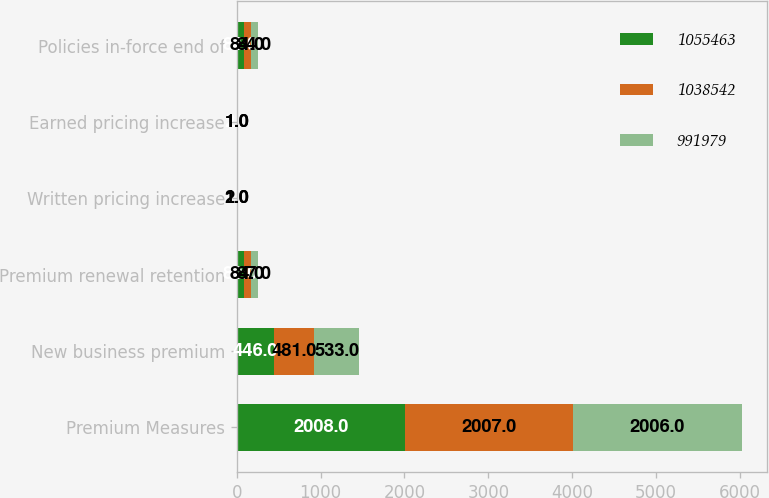Convert chart. <chart><loc_0><loc_0><loc_500><loc_500><stacked_bar_chart><ecel><fcel>Premium Measures<fcel>New business premium<fcel>Premium renewal retention<fcel>Written pricing increase<fcel>Earned pricing increase<fcel>Policies in-force end of<nl><fcel>1.05546e+06<fcel>2008<fcel>446<fcel>82<fcel>2<fcel>2<fcel>84<nl><fcel>1.03854e+06<fcel>2007<fcel>481<fcel>84<fcel>2<fcel>1<fcel>84<nl><fcel>991979<fcel>2006<fcel>533<fcel>87<fcel>1<fcel>1<fcel>84<nl></chart> 